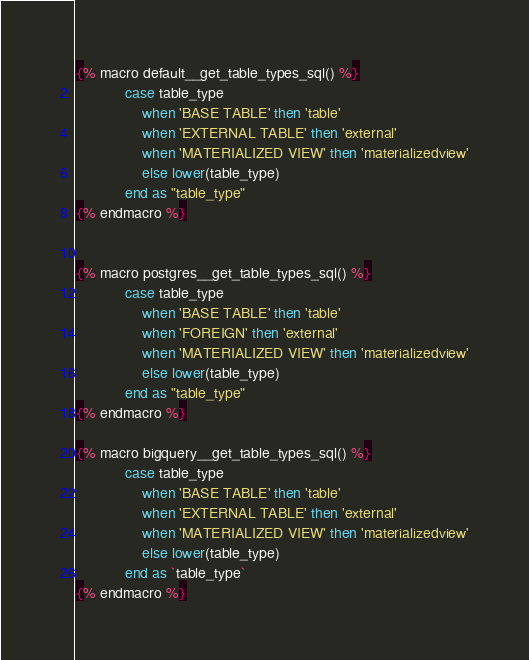<code> <loc_0><loc_0><loc_500><loc_500><_SQL_>{% macro default__get_table_types_sql() %}
            case table_type
                when 'BASE TABLE' then 'table'
                when 'EXTERNAL TABLE' then 'external'
                when 'MATERIALIZED VIEW' then 'materializedview'
                else lower(table_type)
            end as "table_type"
{% endmacro %}


{% macro postgres__get_table_types_sql() %}
            case table_type
                when 'BASE TABLE' then 'table'
                when 'FOREIGN' then 'external'
                when 'MATERIALIZED VIEW' then 'materializedview'
                else lower(table_type)
            end as "table_type"
{% endmacro %}

{% macro bigquery__get_table_types_sql() %}
            case table_type
                when 'BASE TABLE' then 'table'
                when 'EXTERNAL TABLE' then 'external'
                when 'MATERIALIZED VIEW' then 'materializedview'
                else lower(table_type)
            end as `table_type`
{% endmacro %}</code> 